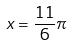<formula> <loc_0><loc_0><loc_500><loc_500>x = \frac { 1 1 } { 6 } \pi</formula> 